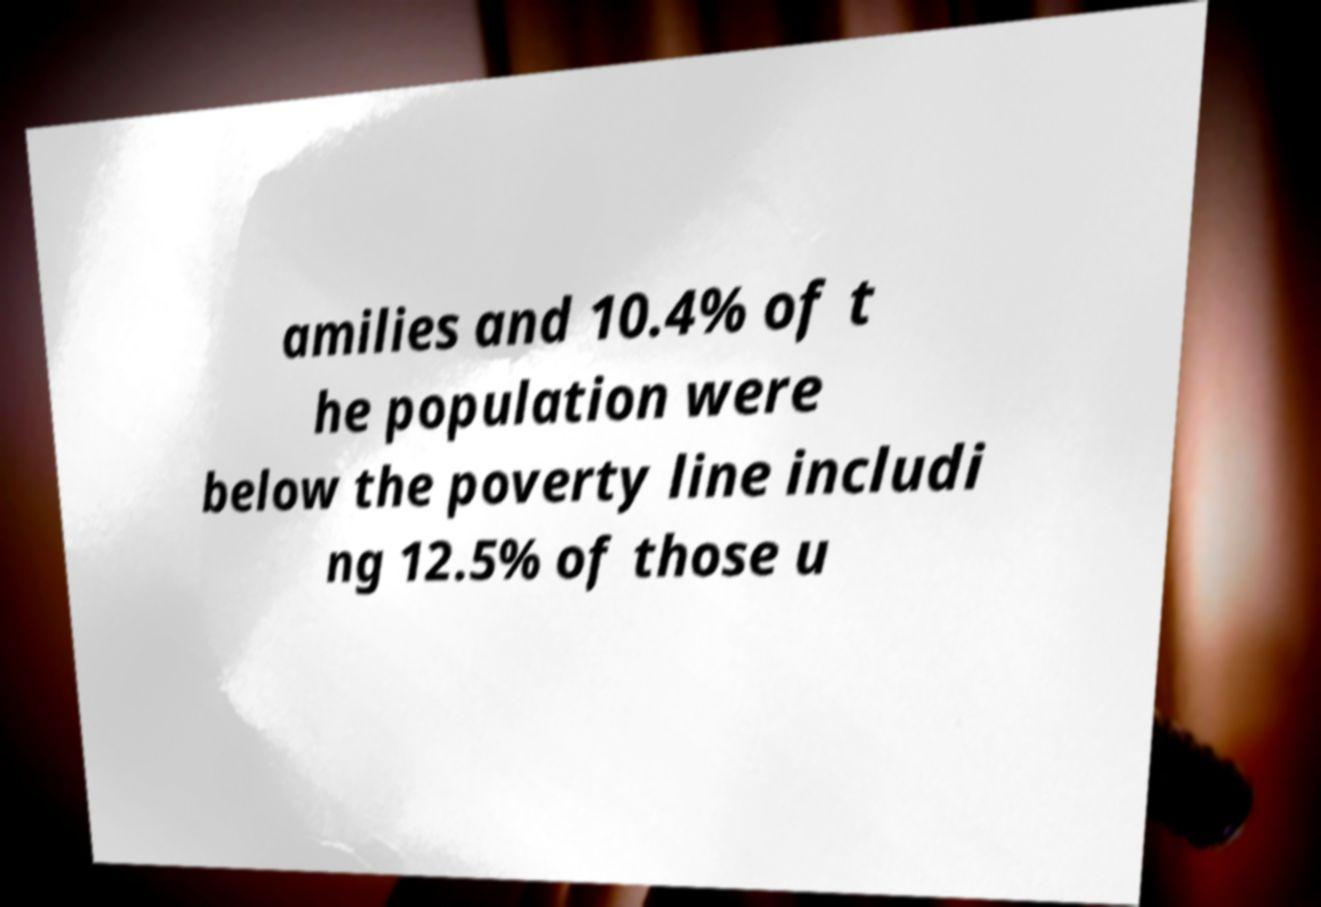What messages or text are displayed in this image? I need them in a readable, typed format. amilies and 10.4% of t he population were below the poverty line includi ng 12.5% of those u 